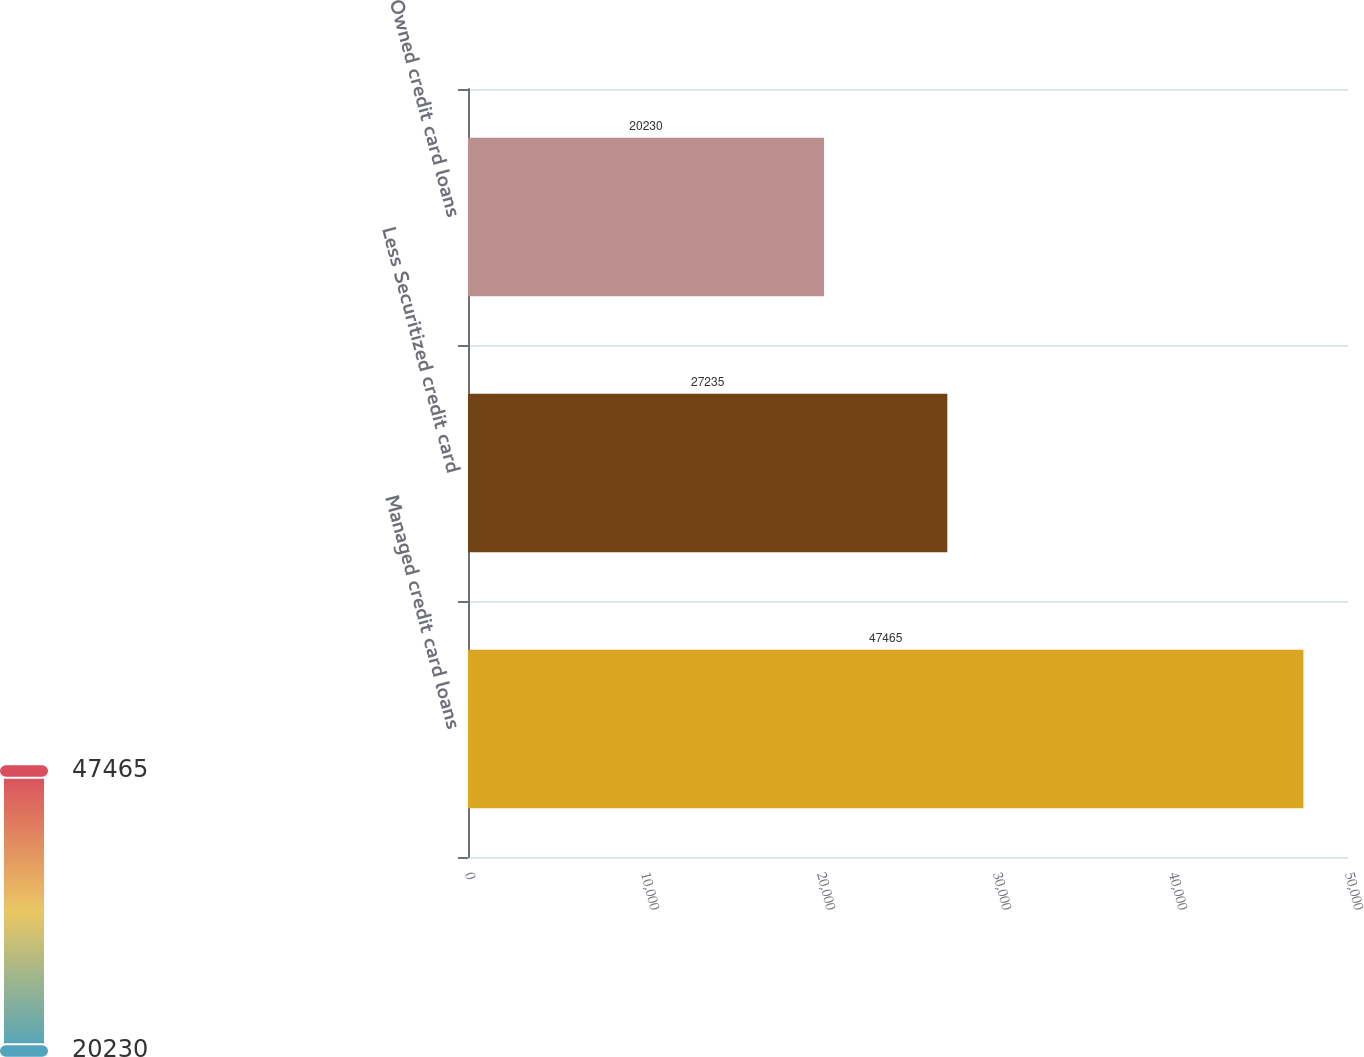Convert chart to OTSL. <chart><loc_0><loc_0><loc_500><loc_500><bar_chart><fcel>Managed credit card loans<fcel>Less Securitized credit card<fcel>Owned credit card loans<nl><fcel>47465<fcel>27235<fcel>20230<nl></chart> 